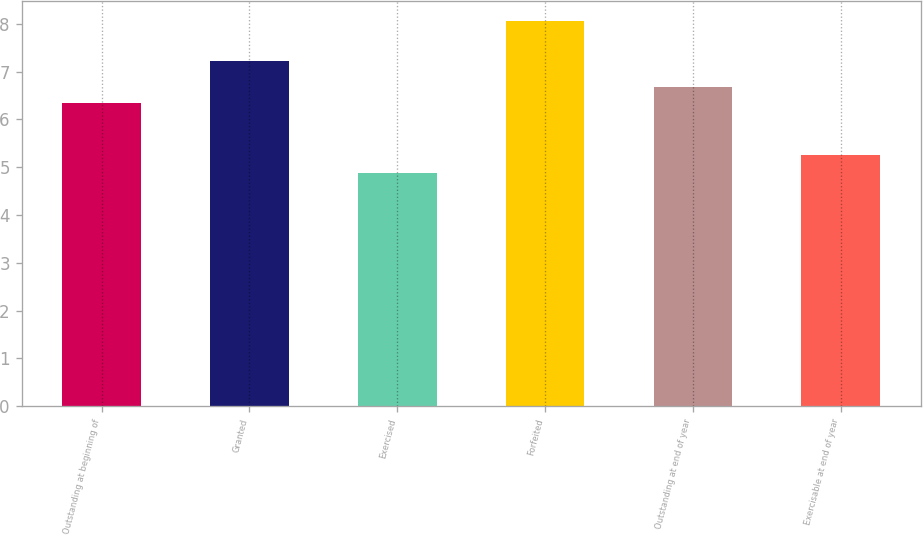<chart> <loc_0><loc_0><loc_500><loc_500><bar_chart><fcel>Outstanding at beginning of<fcel>Granted<fcel>Exercised<fcel>Forfeited<fcel>Outstanding at end of year<fcel>Exercisable at end of year<nl><fcel>6.35<fcel>7.22<fcel>4.87<fcel>8.07<fcel>6.67<fcel>5.26<nl></chart> 